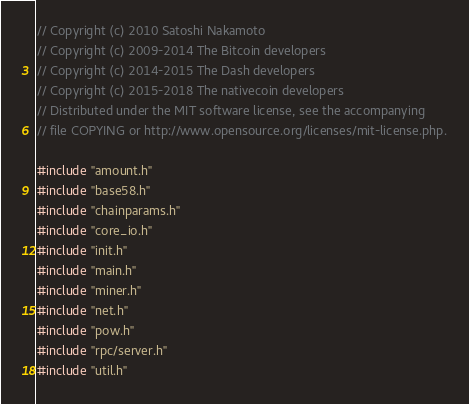Convert code to text. <code><loc_0><loc_0><loc_500><loc_500><_C++_>// Copyright (c) 2010 Satoshi Nakamoto
// Copyright (c) 2009-2014 The Bitcoin developers
// Copyright (c) 2014-2015 The Dash developers
// Copyright (c) 2015-2018 The nativecoin developers
// Distributed under the MIT software license, see the accompanying
// file COPYING or http://www.opensource.org/licenses/mit-license.php.

#include "amount.h"
#include "base58.h"
#include "chainparams.h"
#include "core_io.h"
#include "init.h"
#include "main.h"
#include "miner.h"
#include "net.h"
#include "pow.h"
#include "rpc/server.h"
#include "util.h"</code> 